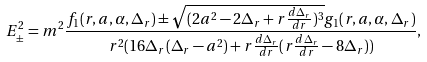<formula> <loc_0><loc_0><loc_500><loc_500>E ^ { 2 } _ { \pm } = m ^ { 2 } \frac { f _ { 1 } ( r , a , \alpha , \Delta _ { r } ) \pm \sqrt { ( 2 a ^ { 2 } - 2 \Delta _ { r } + r \frac { d \Delta _ { r } } { d r } ) ^ { 3 } } g _ { 1 } ( r , a , \alpha , \Delta _ { r } ) } { r ^ { 2 } ( 1 6 \Delta _ { r } ( \Delta _ { r } - a ^ { 2 } ) + r \frac { d \Delta _ { r } } { d r } ( r \frac { d \Delta _ { r } } { d r } - 8 \Delta _ { r } ) ) } ,</formula> 